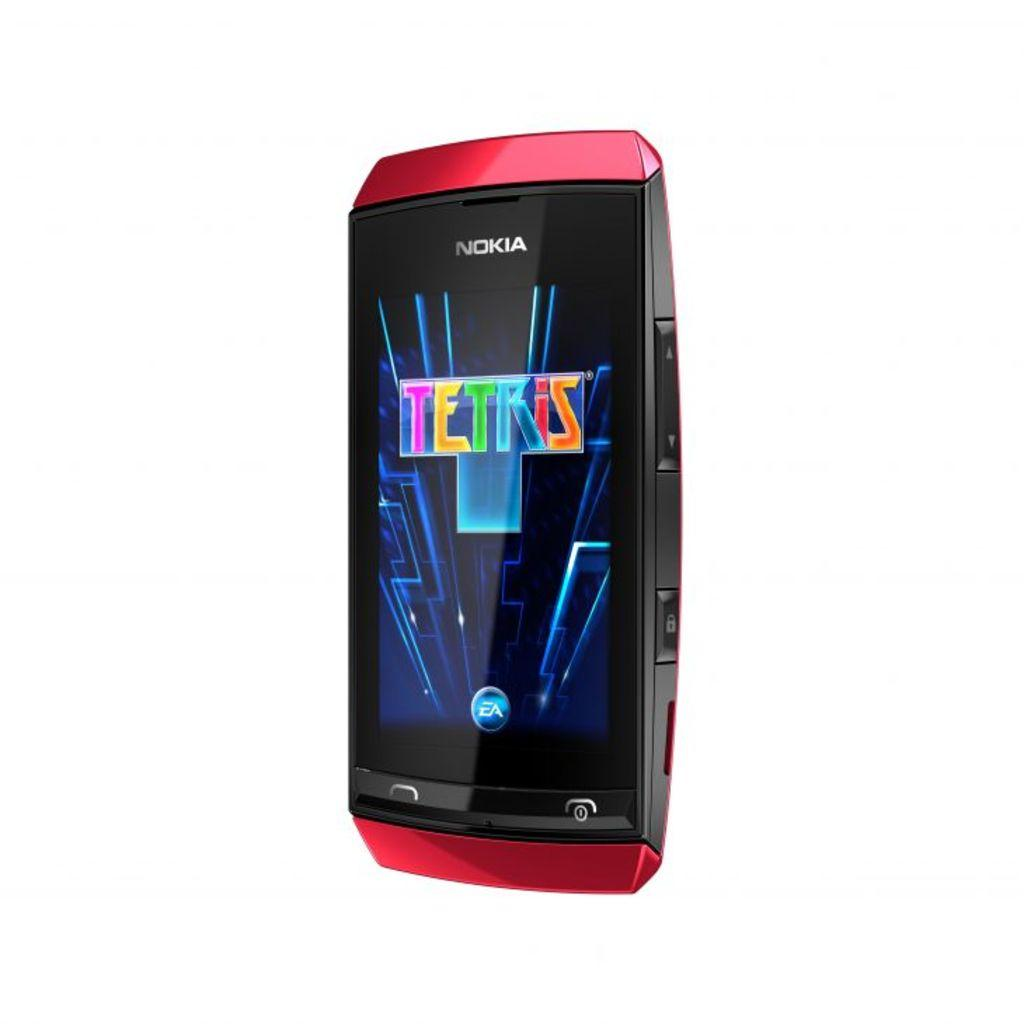<image>
Share a concise interpretation of the image provided. A red Nokia phone has a game on the screen called Tetris. 